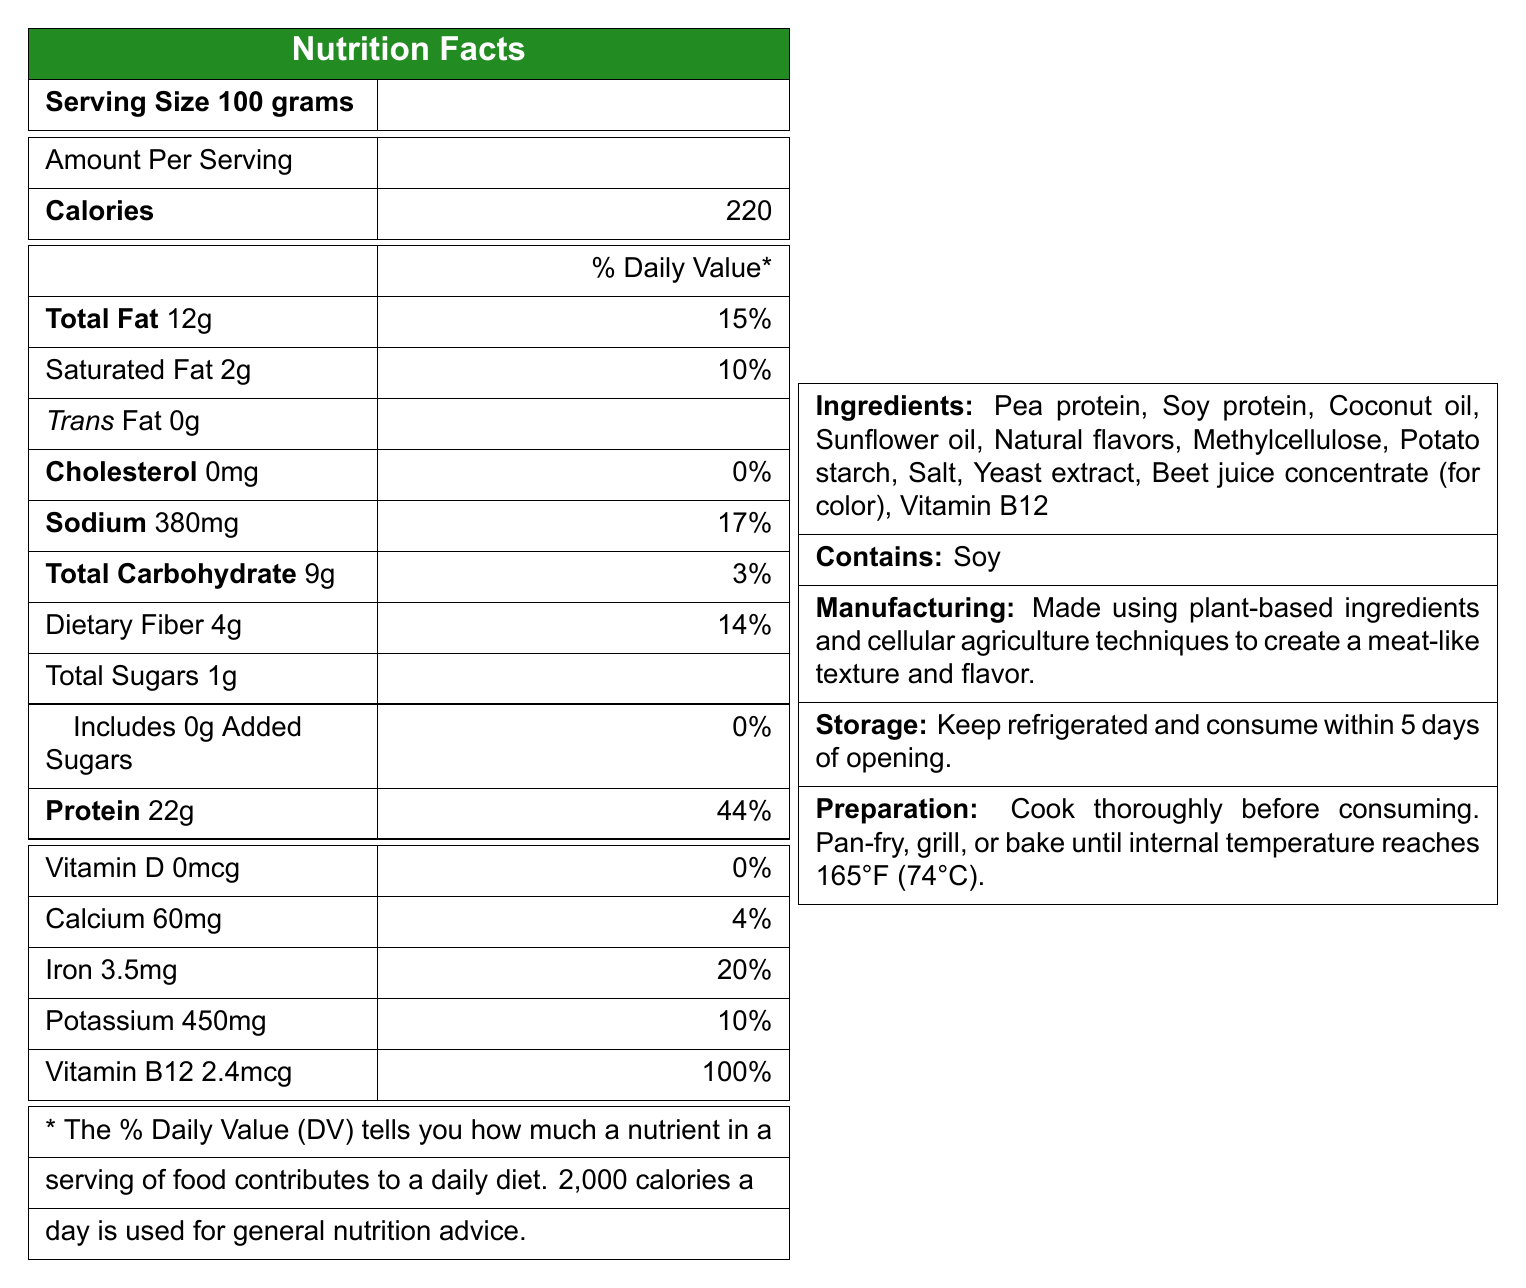what is the serving size for VeggieMeat Supreme? The document states the serving size is 100 grams.
Answer: 100 grams how much protein is in one serving? The document lists 22 grams of protein per serving.
Answer: 22 grams what is the percentage of daily value for sodium? The document mentions that the sodium content per serving is 380mg, which is 17% of the daily value.
Answer: 17% are there any trans fats present in this product? The document indicates that the trans fat content is 0 grams.
Answer: No how much Vitamin D does this product contain? The document states the Vitamin D content is 0 mcg.
Answer: 0 mcg what are the main components of the product? The ingredients list in the document includes these components.
Answer: Pea protein, Soy protein, Coconut oil, Sunflower oil, Natural flavors, Methylcellulose, Potato starch, Salt, Yeast extract, Beet juice concentrate (for color), Vitamin B12 how should this product be stored? Storage instructions in the document specify to keep it refrigerated and consume within 5 days of opening.
Answer: Keep refrigerated and consume within 5 days of opening. what is the total fat content per serving? The document states that the total fat content is 12 grams per serving.
Answer: 12 grams does this product contain cholesterol? According to the document, the cholesterol content is 0 mg.
Answer: No what is the correct internal temperature for cooking this product? The preparation instructions indicate that the internal temperature should reach 165°F (74°C).
Answer: 165°F (74°C) which of the following is an allergen present in the VeggieMeat Supreme? A. Dairy B. Soy C. Wheat D. Nuts The document lists soy as an allergen contained in the product.
Answer: B how much dietary fiber is there per serving? A. 2g B. 4g C. 10g D. 15g The dietary fiber content listed is 4 grams per serving.
Answer: B what percentage of the daily value of protein does one serving provide? The document states that the protein content per serving is 44% of the daily value.
Answer: 44% is this product made using traditional farming techniques? According to the document, it is made using cellular agriculture techniques.
Answer: No can the exact source of coconut oil in VeggieMeat Supreme be determined from the document? The document only lists "Coconut oil" as an ingredient without specifying the source.
Answer: Not enough information what is the main idea of this document? The document covers various details about the product, including its nutritional content, ingredient list, allergen information, and guidelines for storage and preparation.
Answer: The document provides nutritional information, ingredients, allergens, manufacturing, storage, and preparation instructions for VeggieMeat Supreme, a plant-based meat alternative made using cellular agriculture techniques. 